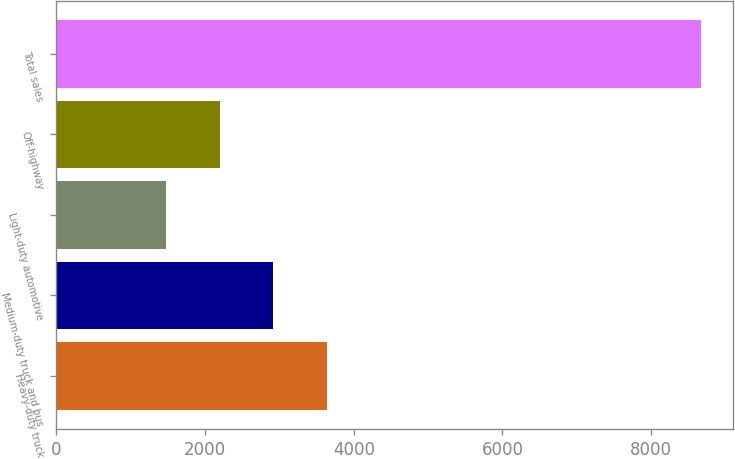Convert chart. <chart><loc_0><loc_0><loc_500><loc_500><bar_chart><fcel>Heavy-duty truck<fcel>Medium-duty truck and bus<fcel>Light-duty automotive<fcel>Off-highway<fcel>Total sales<nl><fcel>3633.5<fcel>2914<fcel>1475<fcel>2194.5<fcel>8670<nl></chart> 